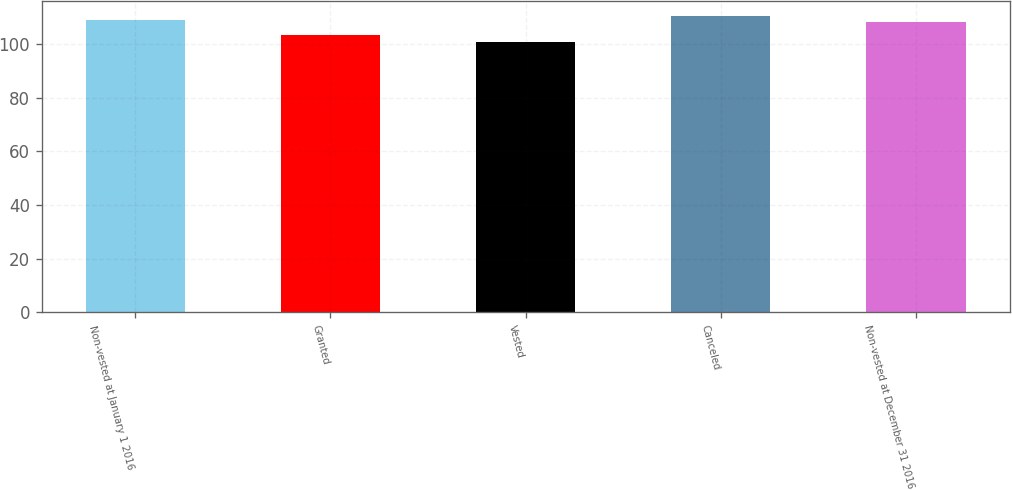Convert chart. <chart><loc_0><loc_0><loc_500><loc_500><bar_chart><fcel>Non-vested at January 1 2016<fcel>Granted<fcel>Vested<fcel>Canceled<fcel>Non-vested at December 31 2016<nl><fcel>109.22<fcel>103.59<fcel>100.7<fcel>110.62<fcel>108.23<nl></chart> 